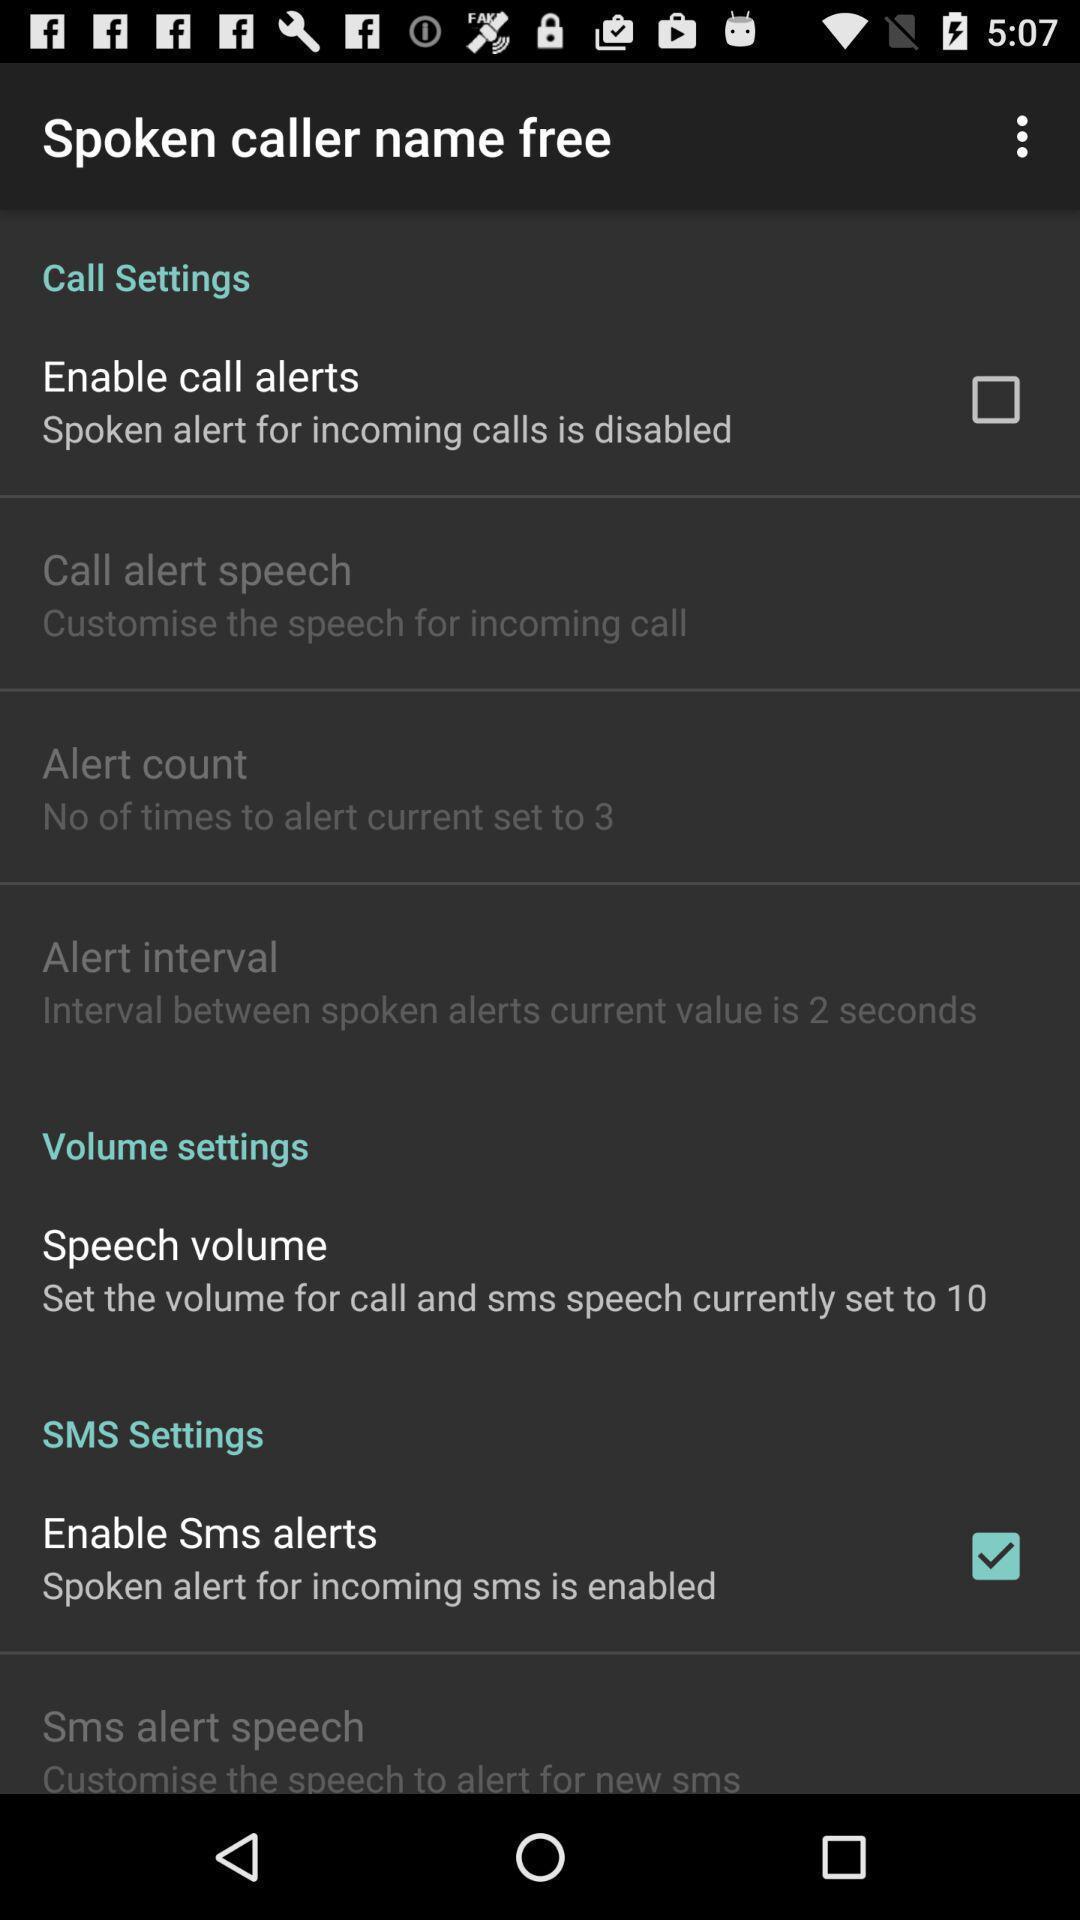Give me a narrative description of this picture. Screen displaying call settings. 